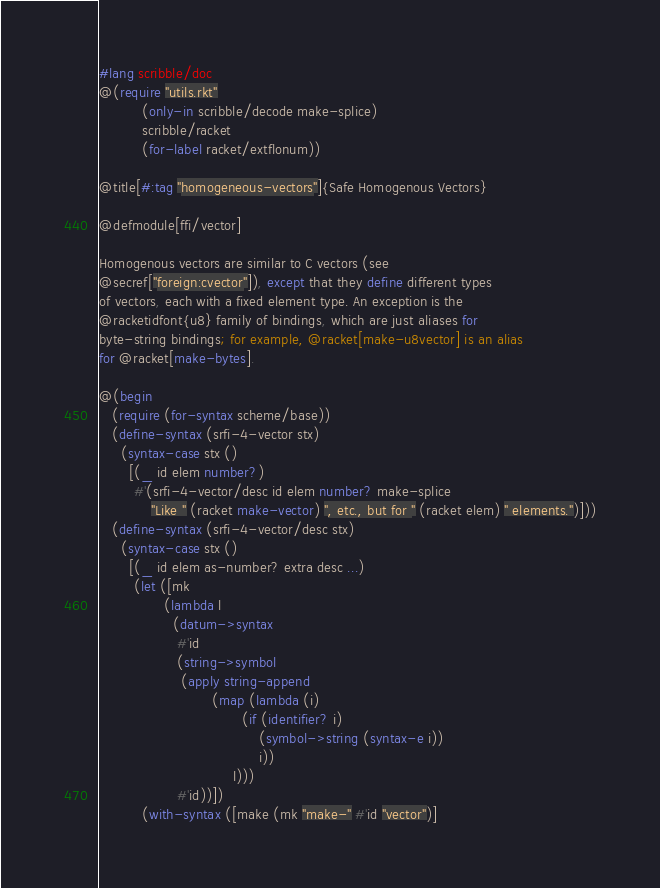<code> <loc_0><loc_0><loc_500><loc_500><_Racket_>#lang scribble/doc
@(require "utils.rkt" 
          (only-in scribble/decode make-splice)
          scribble/racket
          (for-label racket/extflonum))

@title[#:tag "homogeneous-vectors"]{Safe Homogenous Vectors}

@defmodule[ffi/vector]

Homogenous vectors are similar to C vectors (see
@secref["foreign:cvector"]), except that they define different types
of vectors, each with a fixed element type. An exception is the
@racketidfont{u8} family of bindings, which are just aliases for
byte-string bindings; for example, @racket[make-u8vector] is an alias
for @racket[make-bytes].

@(begin
   (require (for-syntax scheme/base))
   (define-syntax (srfi-4-vector stx)
     (syntax-case stx ()
       [(_ id elem number?)
        #'(srfi-4-vector/desc id elem number? make-splice
            "Like " (racket make-vector) ", etc., but for " (racket elem) " elements.")]))
   (define-syntax (srfi-4-vector/desc stx)
     (syntax-case stx ()
       [(_ id elem as-number? extra desc ...)
        (let ([mk
               (lambda l
                 (datum->syntax
                  #'id
                  (string->symbol
                   (apply string-append
                          (map (lambda (i)
                                 (if (identifier? i)
                                     (symbol->string (syntax-e i))
                                     i))
                               l)))
                  #'id))])
          (with-syntax ([make (mk "make-" #'id "vector")]</code> 